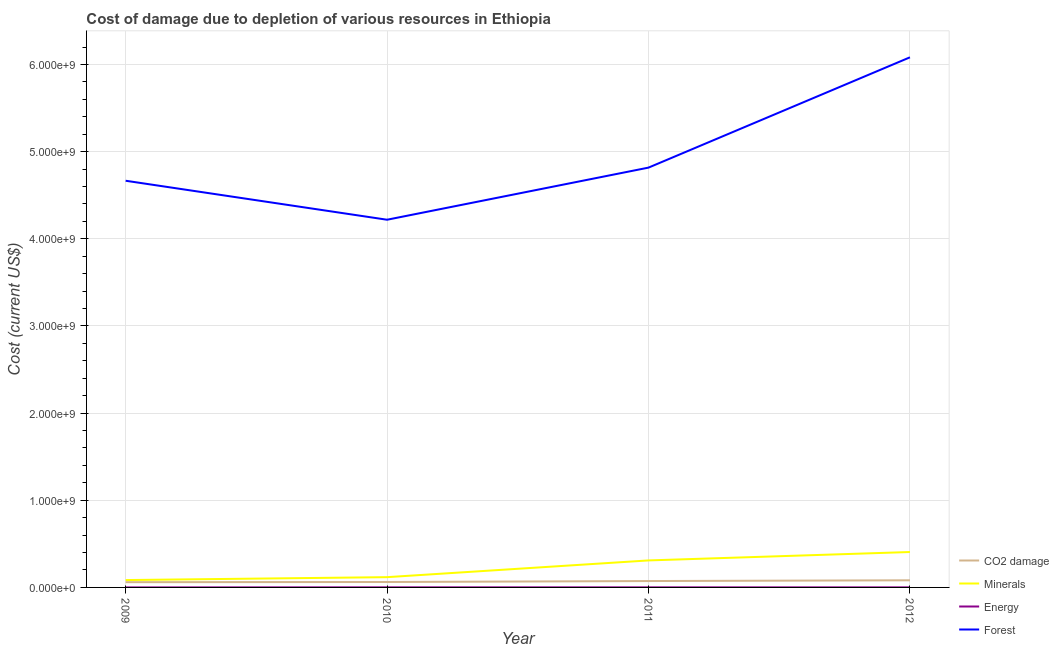Does the line corresponding to cost of damage due to depletion of minerals intersect with the line corresponding to cost of damage due to depletion of coal?
Your answer should be compact. No. Is the number of lines equal to the number of legend labels?
Keep it short and to the point. Yes. What is the cost of damage due to depletion of energy in 2012?
Ensure brevity in your answer.  6.99e+05. Across all years, what is the maximum cost of damage due to depletion of minerals?
Provide a short and direct response. 4.06e+08. Across all years, what is the minimum cost of damage due to depletion of energy?
Your answer should be compact. 2.68e+05. What is the total cost of damage due to depletion of energy in the graph?
Your answer should be very brief. 2.92e+06. What is the difference between the cost of damage due to depletion of energy in 2010 and that in 2011?
Ensure brevity in your answer.  1.36e+05. What is the difference between the cost of damage due to depletion of minerals in 2012 and the cost of damage due to depletion of coal in 2010?
Offer a terse response. 3.44e+08. What is the average cost of damage due to depletion of energy per year?
Your answer should be very brief. 7.30e+05. In the year 2012, what is the difference between the cost of damage due to depletion of minerals and cost of damage due to depletion of energy?
Your answer should be compact. 4.06e+08. In how many years, is the cost of damage due to depletion of forests greater than 5200000000 US$?
Provide a succinct answer. 1. What is the ratio of the cost of damage due to depletion of coal in 2009 to that in 2011?
Your response must be concise. 0.82. Is the cost of damage due to depletion of energy in 2011 less than that in 2012?
Offer a terse response. No. What is the difference between the highest and the second highest cost of damage due to depletion of coal?
Offer a very short reply. 8.60e+06. What is the difference between the highest and the lowest cost of damage due to depletion of minerals?
Provide a succinct answer. 3.22e+08. Is the sum of the cost of damage due to depletion of coal in 2009 and 2012 greater than the maximum cost of damage due to depletion of energy across all years?
Ensure brevity in your answer.  Yes. Does the cost of damage due to depletion of energy monotonically increase over the years?
Your answer should be very brief. No. Is the cost of damage due to depletion of forests strictly less than the cost of damage due to depletion of energy over the years?
Make the answer very short. No. How many lines are there?
Your response must be concise. 4. How many years are there in the graph?
Give a very brief answer. 4. What is the difference between two consecutive major ticks on the Y-axis?
Your answer should be very brief. 1.00e+09. Are the values on the major ticks of Y-axis written in scientific E-notation?
Give a very brief answer. Yes. Where does the legend appear in the graph?
Provide a short and direct response. Bottom right. What is the title of the graph?
Your response must be concise. Cost of damage due to depletion of various resources in Ethiopia . What is the label or title of the Y-axis?
Provide a succinct answer. Cost (current US$). What is the Cost (current US$) in CO2 damage in 2009?
Your answer should be very brief. 6.03e+07. What is the Cost (current US$) in Minerals in 2009?
Offer a very short reply. 8.45e+07. What is the Cost (current US$) in Energy in 2009?
Offer a terse response. 2.68e+05. What is the Cost (current US$) in Forest in 2009?
Your answer should be compact. 4.67e+09. What is the Cost (current US$) in CO2 damage in 2010?
Make the answer very short. 6.22e+07. What is the Cost (current US$) of Minerals in 2010?
Your answer should be compact. 1.18e+08. What is the Cost (current US$) in Energy in 2010?
Your answer should be very brief. 1.04e+06. What is the Cost (current US$) in Forest in 2010?
Offer a terse response. 4.22e+09. What is the Cost (current US$) in CO2 damage in 2011?
Your answer should be very brief. 7.31e+07. What is the Cost (current US$) in Minerals in 2011?
Ensure brevity in your answer.  3.10e+08. What is the Cost (current US$) in Energy in 2011?
Keep it short and to the point. 9.09e+05. What is the Cost (current US$) in Forest in 2011?
Make the answer very short. 4.82e+09. What is the Cost (current US$) of CO2 damage in 2012?
Your response must be concise. 8.17e+07. What is the Cost (current US$) of Minerals in 2012?
Provide a succinct answer. 4.06e+08. What is the Cost (current US$) in Energy in 2012?
Your response must be concise. 6.99e+05. What is the Cost (current US$) in Forest in 2012?
Provide a succinct answer. 6.08e+09. Across all years, what is the maximum Cost (current US$) of CO2 damage?
Keep it short and to the point. 8.17e+07. Across all years, what is the maximum Cost (current US$) of Minerals?
Your response must be concise. 4.06e+08. Across all years, what is the maximum Cost (current US$) of Energy?
Provide a succinct answer. 1.04e+06. Across all years, what is the maximum Cost (current US$) in Forest?
Make the answer very short. 6.08e+09. Across all years, what is the minimum Cost (current US$) in CO2 damage?
Make the answer very short. 6.03e+07. Across all years, what is the minimum Cost (current US$) of Minerals?
Keep it short and to the point. 8.45e+07. Across all years, what is the minimum Cost (current US$) of Energy?
Your response must be concise. 2.68e+05. Across all years, what is the minimum Cost (current US$) in Forest?
Make the answer very short. 4.22e+09. What is the total Cost (current US$) in CO2 damage in the graph?
Give a very brief answer. 2.77e+08. What is the total Cost (current US$) in Minerals in the graph?
Provide a succinct answer. 9.18e+08. What is the total Cost (current US$) of Energy in the graph?
Keep it short and to the point. 2.92e+06. What is the total Cost (current US$) of Forest in the graph?
Offer a terse response. 1.98e+1. What is the difference between the Cost (current US$) in CO2 damage in 2009 and that in 2010?
Your answer should be compact. -1.93e+06. What is the difference between the Cost (current US$) in Minerals in 2009 and that in 2010?
Make the answer very short. -3.32e+07. What is the difference between the Cost (current US$) of Energy in 2009 and that in 2010?
Ensure brevity in your answer.  -7.77e+05. What is the difference between the Cost (current US$) in Forest in 2009 and that in 2010?
Your answer should be compact. 4.47e+08. What is the difference between the Cost (current US$) of CO2 damage in 2009 and that in 2011?
Provide a succinct answer. -1.28e+07. What is the difference between the Cost (current US$) in Minerals in 2009 and that in 2011?
Provide a succinct answer. -2.25e+08. What is the difference between the Cost (current US$) of Energy in 2009 and that in 2011?
Ensure brevity in your answer.  -6.41e+05. What is the difference between the Cost (current US$) of Forest in 2009 and that in 2011?
Your response must be concise. -1.51e+08. What is the difference between the Cost (current US$) of CO2 damage in 2009 and that in 2012?
Ensure brevity in your answer.  -2.14e+07. What is the difference between the Cost (current US$) in Minerals in 2009 and that in 2012?
Provide a short and direct response. -3.22e+08. What is the difference between the Cost (current US$) of Energy in 2009 and that in 2012?
Provide a short and direct response. -4.31e+05. What is the difference between the Cost (current US$) in Forest in 2009 and that in 2012?
Keep it short and to the point. -1.42e+09. What is the difference between the Cost (current US$) in CO2 damage in 2010 and that in 2011?
Your response must be concise. -1.09e+07. What is the difference between the Cost (current US$) in Minerals in 2010 and that in 2011?
Provide a succinct answer. -1.92e+08. What is the difference between the Cost (current US$) of Energy in 2010 and that in 2011?
Your answer should be compact. 1.36e+05. What is the difference between the Cost (current US$) of Forest in 2010 and that in 2011?
Your answer should be very brief. -5.98e+08. What is the difference between the Cost (current US$) in CO2 damage in 2010 and that in 2012?
Your answer should be compact. -1.95e+07. What is the difference between the Cost (current US$) in Minerals in 2010 and that in 2012?
Offer a terse response. -2.88e+08. What is the difference between the Cost (current US$) in Energy in 2010 and that in 2012?
Give a very brief answer. 3.46e+05. What is the difference between the Cost (current US$) of Forest in 2010 and that in 2012?
Your response must be concise. -1.86e+09. What is the difference between the Cost (current US$) of CO2 damage in 2011 and that in 2012?
Provide a succinct answer. -8.60e+06. What is the difference between the Cost (current US$) in Minerals in 2011 and that in 2012?
Your answer should be very brief. -9.64e+07. What is the difference between the Cost (current US$) in Energy in 2011 and that in 2012?
Your answer should be very brief. 2.10e+05. What is the difference between the Cost (current US$) of Forest in 2011 and that in 2012?
Provide a succinct answer. -1.27e+09. What is the difference between the Cost (current US$) in CO2 damage in 2009 and the Cost (current US$) in Minerals in 2010?
Offer a very short reply. -5.75e+07. What is the difference between the Cost (current US$) of CO2 damage in 2009 and the Cost (current US$) of Energy in 2010?
Provide a succinct answer. 5.92e+07. What is the difference between the Cost (current US$) of CO2 damage in 2009 and the Cost (current US$) of Forest in 2010?
Give a very brief answer. -4.16e+09. What is the difference between the Cost (current US$) in Minerals in 2009 and the Cost (current US$) in Energy in 2010?
Ensure brevity in your answer.  8.35e+07. What is the difference between the Cost (current US$) in Minerals in 2009 and the Cost (current US$) in Forest in 2010?
Give a very brief answer. -4.13e+09. What is the difference between the Cost (current US$) of Energy in 2009 and the Cost (current US$) of Forest in 2010?
Your answer should be very brief. -4.22e+09. What is the difference between the Cost (current US$) in CO2 damage in 2009 and the Cost (current US$) in Minerals in 2011?
Your answer should be compact. -2.50e+08. What is the difference between the Cost (current US$) in CO2 damage in 2009 and the Cost (current US$) in Energy in 2011?
Provide a succinct answer. 5.94e+07. What is the difference between the Cost (current US$) in CO2 damage in 2009 and the Cost (current US$) in Forest in 2011?
Provide a succinct answer. -4.76e+09. What is the difference between the Cost (current US$) in Minerals in 2009 and the Cost (current US$) in Energy in 2011?
Provide a short and direct response. 8.36e+07. What is the difference between the Cost (current US$) in Minerals in 2009 and the Cost (current US$) in Forest in 2011?
Make the answer very short. -4.73e+09. What is the difference between the Cost (current US$) of Energy in 2009 and the Cost (current US$) of Forest in 2011?
Provide a succinct answer. -4.82e+09. What is the difference between the Cost (current US$) in CO2 damage in 2009 and the Cost (current US$) in Minerals in 2012?
Provide a short and direct response. -3.46e+08. What is the difference between the Cost (current US$) in CO2 damage in 2009 and the Cost (current US$) in Energy in 2012?
Provide a short and direct response. 5.96e+07. What is the difference between the Cost (current US$) in CO2 damage in 2009 and the Cost (current US$) in Forest in 2012?
Make the answer very short. -6.02e+09. What is the difference between the Cost (current US$) in Minerals in 2009 and the Cost (current US$) in Energy in 2012?
Your answer should be very brief. 8.38e+07. What is the difference between the Cost (current US$) in Minerals in 2009 and the Cost (current US$) in Forest in 2012?
Your answer should be very brief. -6.00e+09. What is the difference between the Cost (current US$) of Energy in 2009 and the Cost (current US$) of Forest in 2012?
Offer a terse response. -6.08e+09. What is the difference between the Cost (current US$) in CO2 damage in 2010 and the Cost (current US$) in Minerals in 2011?
Offer a very short reply. -2.48e+08. What is the difference between the Cost (current US$) of CO2 damage in 2010 and the Cost (current US$) of Energy in 2011?
Give a very brief answer. 6.13e+07. What is the difference between the Cost (current US$) in CO2 damage in 2010 and the Cost (current US$) in Forest in 2011?
Provide a succinct answer. -4.75e+09. What is the difference between the Cost (current US$) in Minerals in 2010 and the Cost (current US$) in Energy in 2011?
Offer a terse response. 1.17e+08. What is the difference between the Cost (current US$) in Minerals in 2010 and the Cost (current US$) in Forest in 2011?
Keep it short and to the point. -4.70e+09. What is the difference between the Cost (current US$) of Energy in 2010 and the Cost (current US$) of Forest in 2011?
Give a very brief answer. -4.82e+09. What is the difference between the Cost (current US$) in CO2 damage in 2010 and the Cost (current US$) in Minerals in 2012?
Ensure brevity in your answer.  -3.44e+08. What is the difference between the Cost (current US$) of CO2 damage in 2010 and the Cost (current US$) of Energy in 2012?
Keep it short and to the point. 6.15e+07. What is the difference between the Cost (current US$) of CO2 damage in 2010 and the Cost (current US$) of Forest in 2012?
Provide a short and direct response. -6.02e+09. What is the difference between the Cost (current US$) in Minerals in 2010 and the Cost (current US$) in Energy in 2012?
Make the answer very short. 1.17e+08. What is the difference between the Cost (current US$) in Minerals in 2010 and the Cost (current US$) in Forest in 2012?
Your answer should be compact. -5.96e+09. What is the difference between the Cost (current US$) of Energy in 2010 and the Cost (current US$) of Forest in 2012?
Your answer should be very brief. -6.08e+09. What is the difference between the Cost (current US$) in CO2 damage in 2011 and the Cost (current US$) in Minerals in 2012?
Provide a succinct answer. -3.33e+08. What is the difference between the Cost (current US$) of CO2 damage in 2011 and the Cost (current US$) of Energy in 2012?
Give a very brief answer. 7.24e+07. What is the difference between the Cost (current US$) in CO2 damage in 2011 and the Cost (current US$) in Forest in 2012?
Your answer should be very brief. -6.01e+09. What is the difference between the Cost (current US$) of Minerals in 2011 and the Cost (current US$) of Energy in 2012?
Make the answer very short. 3.09e+08. What is the difference between the Cost (current US$) of Minerals in 2011 and the Cost (current US$) of Forest in 2012?
Your answer should be very brief. -5.77e+09. What is the difference between the Cost (current US$) of Energy in 2011 and the Cost (current US$) of Forest in 2012?
Provide a short and direct response. -6.08e+09. What is the average Cost (current US$) in CO2 damage per year?
Your answer should be very brief. 6.93e+07. What is the average Cost (current US$) in Minerals per year?
Your response must be concise. 2.30e+08. What is the average Cost (current US$) of Energy per year?
Provide a short and direct response. 7.30e+05. What is the average Cost (current US$) of Forest per year?
Provide a short and direct response. 4.95e+09. In the year 2009, what is the difference between the Cost (current US$) in CO2 damage and Cost (current US$) in Minerals?
Your response must be concise. -2.43e+07. In the year 2009, what is the difference between the Cost (current US$) of CO2 damage and Cost (current US$) of Energy?
Your response must be concise. 6.00e+07. In the year 2009, what is the difference between the Cost (current US$) of CO2 damage and Cost (current US$) of Forest?
Offer a very short reply. -4.61e+09. In the year 2009, what is the difference between the Cost (current US$) in Minerals and Cost (current US$) in Energy?
Make the answer very short. 8.43e+07. In the year 2009, what is the difference between the Cost (current US$) of Minerals and Cost (current US$) of Forest?
Offer a very short reply. -4.58e+09. In the year 2009, what is the difference between the Cost (current US$) of Energy and Cost (current US$) of Forest?
Your response must be concise. -4.67e+09. In the year 2010, what is the difference between the Cost (current US$) in CO2 damage and Cost (current US$) in Minerals?
Provide a succinct answer. -5.56e+07. In the year 2010, what is the difference between the Cost (current US$) in CO2 damage and Cost (current US$) in Energy?
Ensure brevity in your answer.  6.12e+07. In the year 2010, what is the difference between the Cost (current US$) in CO2 damage and Cost (current US$) in Forest?
Make the answer very short. -4.16e+09. In the year 2010, what is the difference between the Cost (current US$) in Minerals and Cost (current US$) in Energy?
Offer a very short reply. 1.17e+08. In the year 2010, what is the difference between the Cost (current US$) of Minerals and Cost (current US$) of Forest?
Offer a terse response. -4.10e+09. In the year 2010, what is the difference between the Cost (current US$) of Energy and Cost (current US$) of Forest?
Your response must be concise. -4.22e+09. In the year 2011, what is the difference between the Cost (current US$) of CO2 damage and Cost (current US$) of Minerals?
Provide a succinct answer. -2.37e+08. In the year 2011, what is the difference between the Cost (current US$) in CO2 damage and Cost (current US$) in Energy?
Provide a succinct answer. 7.22e+07. In the year 2011, what is the difference between the Cost (current US$) of CO2 damage and Cost (current US$) of Forest?
Give a very brief answer. -4.74e+09. In the year 2011, what is the difference between the Cost (current US$) of Minerals and Cost (current US$) of Energy?
Provide a succinct answer. 3.09e+08. In the year 2011, what is the difference between the Cost (current US$) in Minerals and Cost (current US$) in Forest?
Offer a terse response. -4.51e+09. In the year 2011, what is the difference between the Cost (current US$) of Energy and Cost (current US$) of Forest?
Your answer should be very brief. -4.82e+09. In the year 2012, what is the difference between the Cost (current US$) in CO2 damage and Cost (current US$) in Minerals?
Your answer should be very brief. -3.24e+08. In the year 2012, what is the difference between the Cost (current US$) of CO2 damage and Cost (current US$) of Energy?
Give a very brief answer. 8.10e+07. In the year 2012, what is the difference between the Cost (current US$) in CO2 damage and Cost (current US$) in Forest?
Your response must be concise. -6.00e+09. In the year 2012, what is the difference between the Cost (current US$) of Minerals and Cost (current US$) of Energy?
Give a very brief answer. 4.06e+08. In the year 2012, what is the difference between the Cost (current US$) of Minerals and Cost (current US$) of Forest?
Your answer should be very brief. -5.68e+09. In the year 2012, what is the difference between the Cost (current US$) in Energy and Cost (current US$) in Forest?
Your answer should be compact. -6.08e+09. What is the ratio of the Cost (current US$) in Minerals in 2009 to that in 2010?
Your answer should be very brief. 0.72. What is the ratio of the Cost (current US$) in Energy in 2009 to that in 2010?
Your answer should be very brief. 0.26. What is the ratio of the Cost (current US$) of Forest in 2009 to that in 2010?
Ensure brevity in your answer.  1.11. What is the ratio of the Cost (current US$) in CO2 damage in 2009 to that in 2011?
Your answer should be very brief. 0.82. What is the ratio of the Cost (current US$) in Minerals in 2009 to that in 2011?
Give a very brief answer. 0.27. What is the ratio of the Cost (current US$) of Energy in 2009 to that in 2011?
Provide a short and direct response. 0.29. What is the ratio of the Cost (current US$) of Forest in 2009 to that in 2011?
Ensure brevity in your answer.  0.97. What is the ratio of the Cost (current US$) in CO2 damage in 2009 to that in 2012?
Ensure brevity in your answer.  0.74. What is the ratio of the Cost (current US$) of Minerals in 2009 to that in 2012?
Offer a terse response. 0.21. What is the ratio of the Cost (current US$) in Energy in 2009 to that in 2012?
Offer a very short reply. 0.38. What is the ratio of the Cost (current US$) in Forest in 2009 to that in 2012?
Make the answer very short. 0.77. What is the ratio of the Cost (current US$) of CO2 damage in 2010 to that in 2011?
Ensure brevity in your answer.  0.85. What is the ratio of the Cost (current US$) in Minerals in 2010 to that in 2011?
Provide a short and direct response. 0.38. What is the ratio of the Cost (current US$) in Energy in 2010 to that in 2011?
Offer a terse response. 1.15. What is the ratio of the Cost (current US$) in Forest in 2010 to that in 2011?
Your answer should be compact. 0.88. What is the ratio of the Cost (current US$) in CO2 damage in 2010 to that in 2012?
Provide a succinct answer. 0.76. What is the ratio of the Cost (current US$) in Minerals in 2010 to that in 2012?
Offer a terse response. 0.29. What is the ratio of the Cost (current US$) of Energy in 2010 to that in 2012?
Your response must be concise. 1.5. What is the ratio of the Cost (current US$) in Forest in 2010 to that in 2012?
Your answer should be compact. 0.69. What is the ratio of the Cost (current US$) of CO2 damage in 2011 to that in 2012?
Offer a terse response. 0.89. What is the ratio of the Cost (current US$) in Minerals in 2011 to that in 2012?
Your answer should be very brief. 0.76. What is the ratio of the Cost (current US$) of Energy in 2011 to that in 2012?
Your answer should be compact. 1.3. What is the ratio of the Cost (current US$) in Forest in 2011 to that in 2012?
Provide a succinct answer. 0.79. What is the difference between the highest and the second highest Cost (current US$) of CO2 damage?
Offer a very short reply. 8.60e+06. What is the difference between the highest and the second highest Cost (current US$) in Minerals?
Ensure brevity in your answer.  9.64e+07. What is the difference between the highest and the second highest Cost (current US$) of Energy?
Your response must be concise. 1.36e+05. What is the difference between the highest and the second highest Cost (current US$) of Forest?
Offer a terse response. 1.27e+09. What is the difference between the highest and the lowest Cost (current US$) in CO2 damage?
Provide a short and direct response. 2.14e+07. What is the difference between the highest and the lowest Cost (current US$) of Minerals?
Ensure brevity in your answer.  3.22e+08. What is the difference between the highest and the lowest Cost (current US$) of Energy?
Keep it short and to the point. 7.77e+05. What is the difference between the highest and the lowest Cost (current US$) in Forest?
Your answer should be compact. 1.86e+09. 